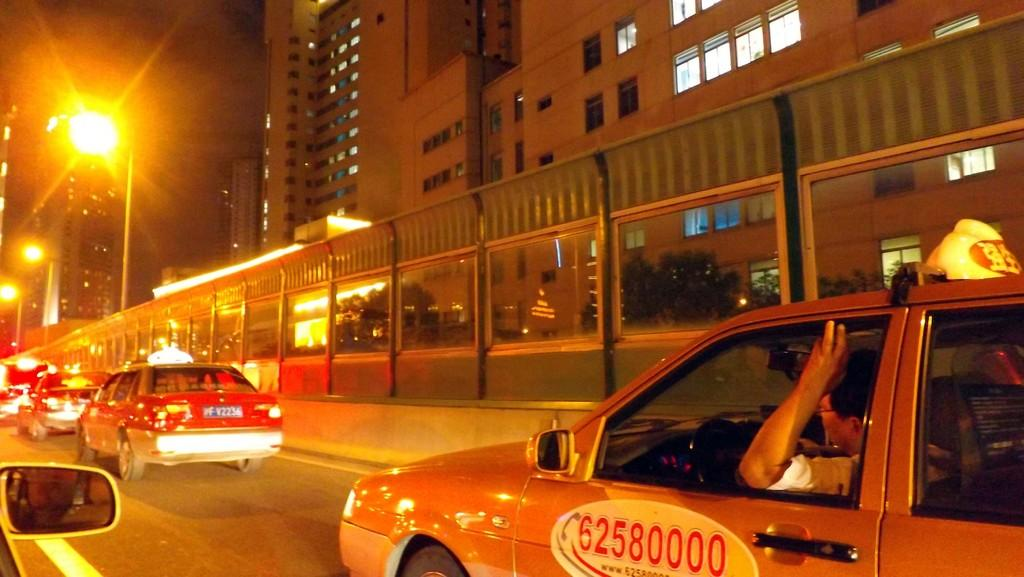<image>
Render a clear and concise summary of the photo. A yellow cab with the phone number of 62580000 on the driver's side door. 